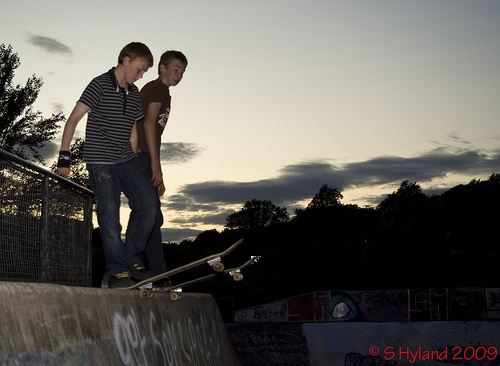Describe the objects in this image and their specific colors. I can see people in darkgray, black, gray, and maroon tones, people in darkgray, black, maroon, and gray tones, skateboard in darkgray, black, and gray tones, and skateboard in darkgray, black, and gray tones in this image. 